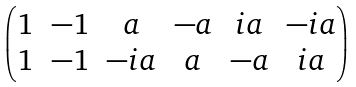<formula> <loc_0><loc_0><loc_500><loc_500>\begin{pmatrix} 1 & - 1 & a & - a & i a & - i a \\ 1 & - 1 & - i a & a & - a & i a \end{pmatrix}</formula> 